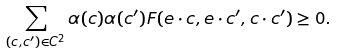<formula> <loc_0><loc_0><loc_500><loc_500>\sum _ { ( c , c ^ { \prime } ) \in C ^ { 2 } } \alpha ( c ) \alpha ( c ^ { \prime } ) F ( e \cdot c , e \cdot c ^ { \prime } , c \cdot c ^ { \prime } ) \geq 0 .</formula> 